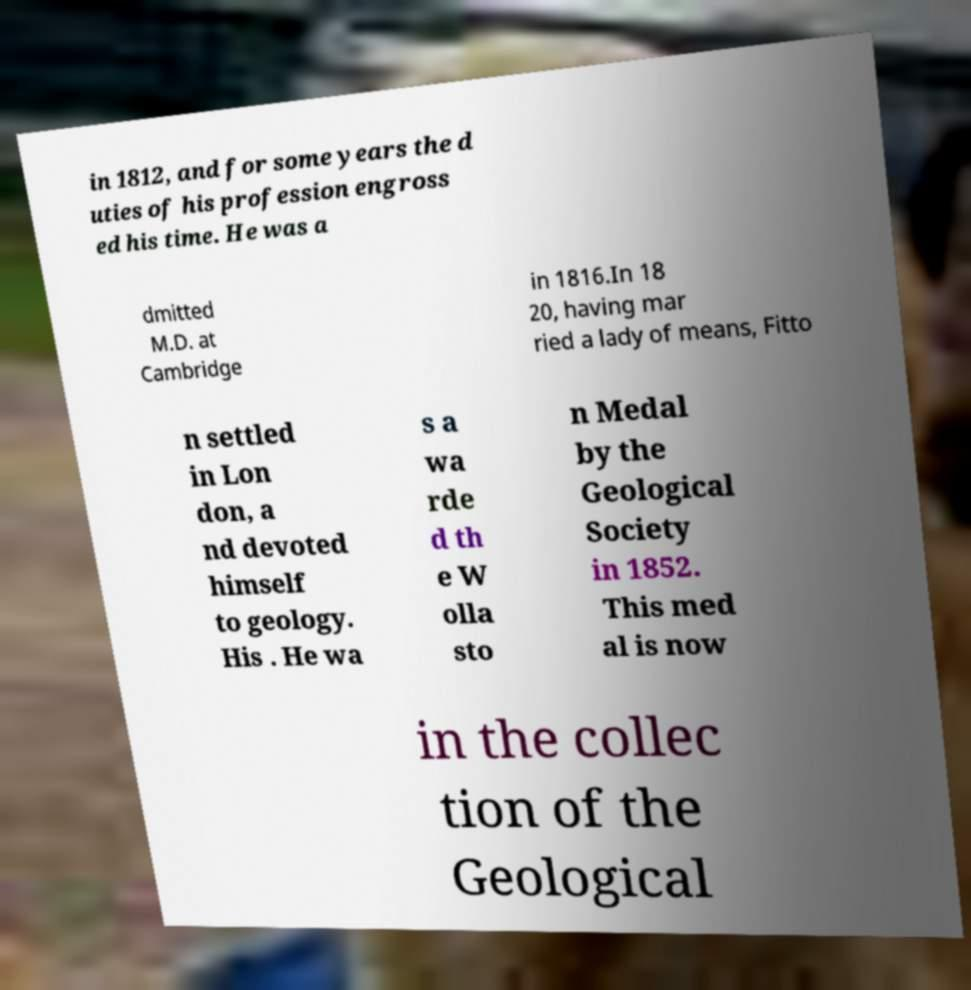Could you extract and type out the text from this image? in 1812, and for some years the d uties of his profession engross ed his time. He was a dmitted M.D. at Cambridge in 1816.In 18 20, having mar ried a lady of means, Fitto n settled in Lon don, a nd devoted himself to geology. His . He wa s a wa rde d th e W olla sto n Medal by the Geological Society in 1852. This med al is now in the collec tion of the Geological 